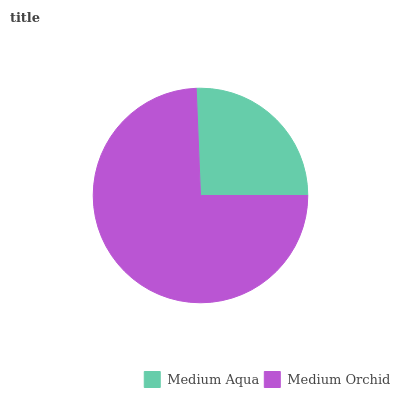Is Medium Aqua the minimum?
Answer yes or no. Yes. Is Medium Orchid the maximum?
Answer yes or no. Yes. Is Medium Orchid the minimum?
Answer yes or no. No. Is Medium Orchid greater than Medium Aqua?
Answer yes or no. Yes. Is Medium Aqua less than Medium Orchid?
Answer yes or no. Yes. Is Medium Aqua greater than Medium Orchid?
Answer yes or no. No. Is Medium Orchid less than Medium Aqua?
Answer yes or no. No. Is Medium Orchid the high median?
Answer yes or no. Yes. Is Medium Aqua the low median?
Answer yes or no. Yes. Is Medium Aqua the high median?
Answer yes or no. No. Is Medium Orchid the low median?
Answer yes or no. No. 